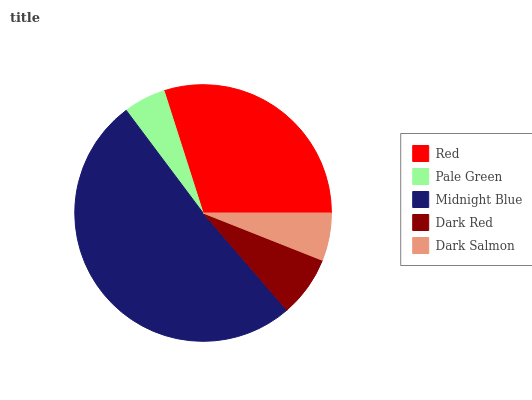Is Pale Green the minimum?
Answer yes or no. Yes. Is Midnight Blue the maximum?
Answer yes or no. Yes. Is Midnight Blue the minimum?
Answer yes or no. No. Is Pale Green the maximum?
Answer yes or no. No. Is Midnight Blue greater than Pale Green?
Answer yes or no. Yes. Is Pale Green less than Midnight Blue?
Answer yes or no. Yes. Is Pale Green greater than Midnight Blue?
Answer yes or no. No. Is Midnight Blue less than Pale Green?
Answer yes or no. No. Is Dark Red the high median?
Answer yes or no. Yes. Is Dark Red the low median?
Answer yes or no. Yes. Is Pale Green the high median?
Answer yes or no. No. Is Red the low median?
Answer yes or no. No. 